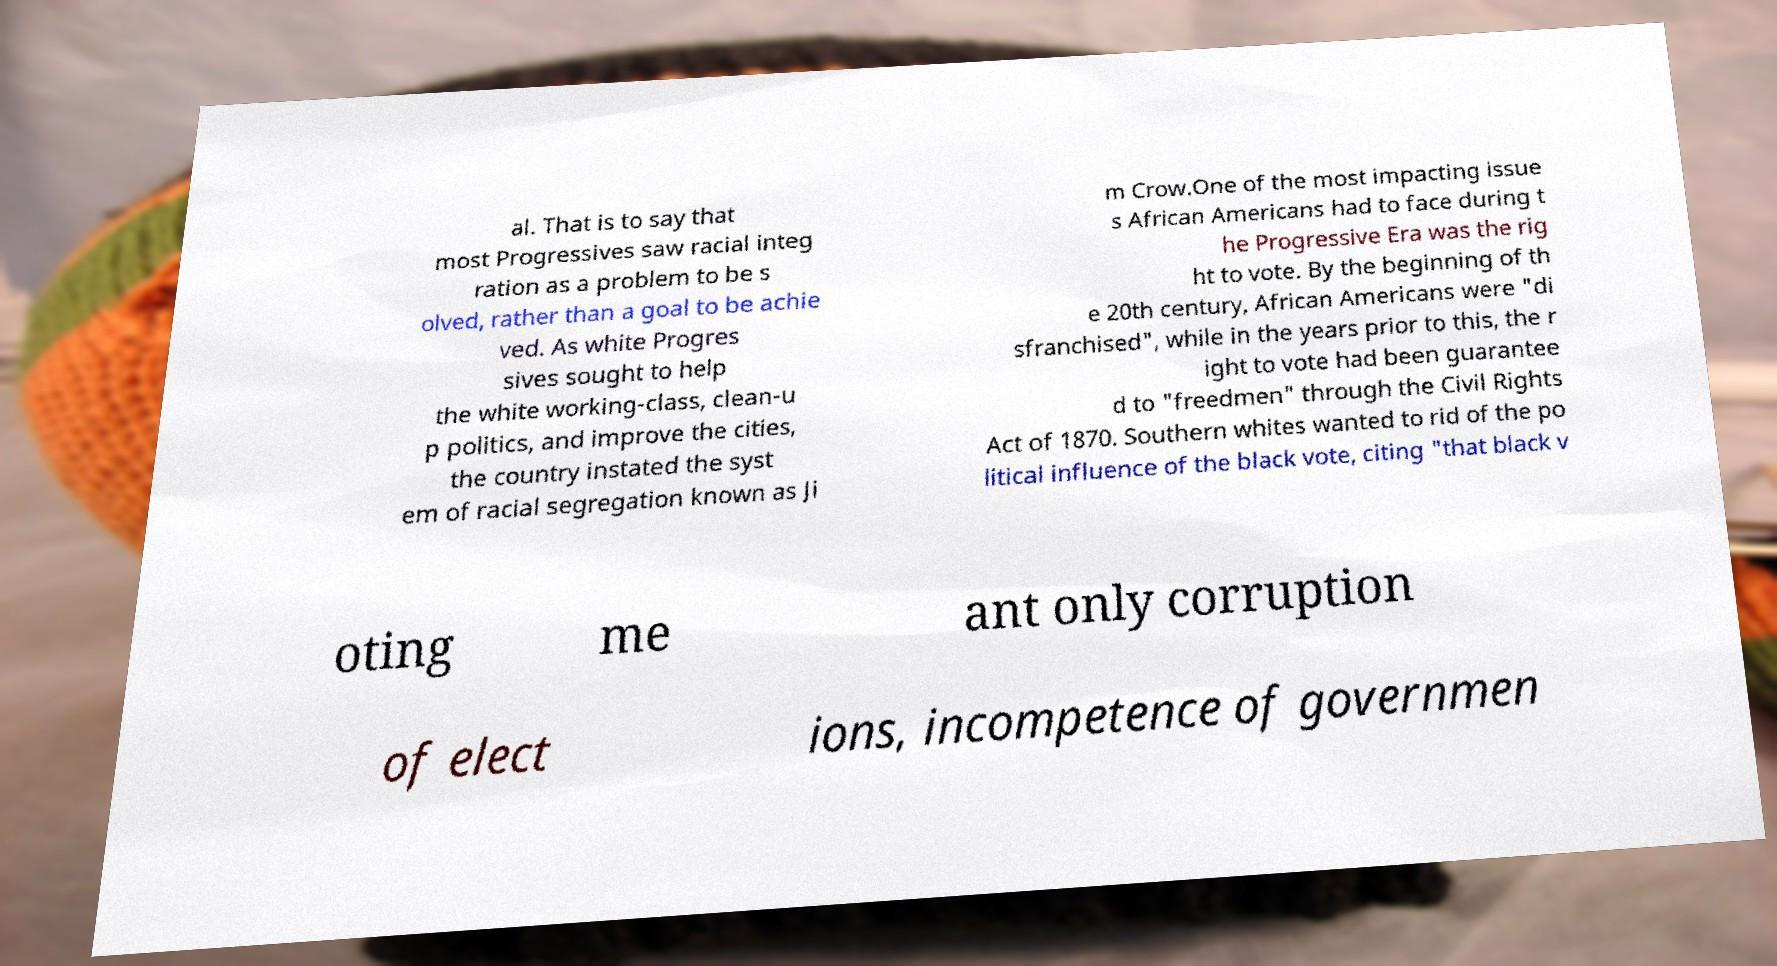Can you read and provide the text displayed in the image?This photo seems to have some interesting text. Can you extract and type it out for me? al. That is to say that most Progressives saw racial integ ration as a problem to be s olved, rather than a goal to be achie ved. As white Progres sives sought to help the white working-class, clean-u p politics, and improve the cities, the country instated the syst em of racial segregation known as Ji m Crow.One of the most impacting issue s African Americans had to face during t he Progressive Era was the rig ht to vote. By the beginning of th e 20th century, African Americans were "di sfranchised", while in the years prior to this, the r ight to vote had been guarantee d to "freedmen" through the Civil Rights Act of 1870. Southern whites wanted to rid of the po litical influence of the black vote, citing "that black v oting me ant only corruption of elect ions, incompetence of governmen 